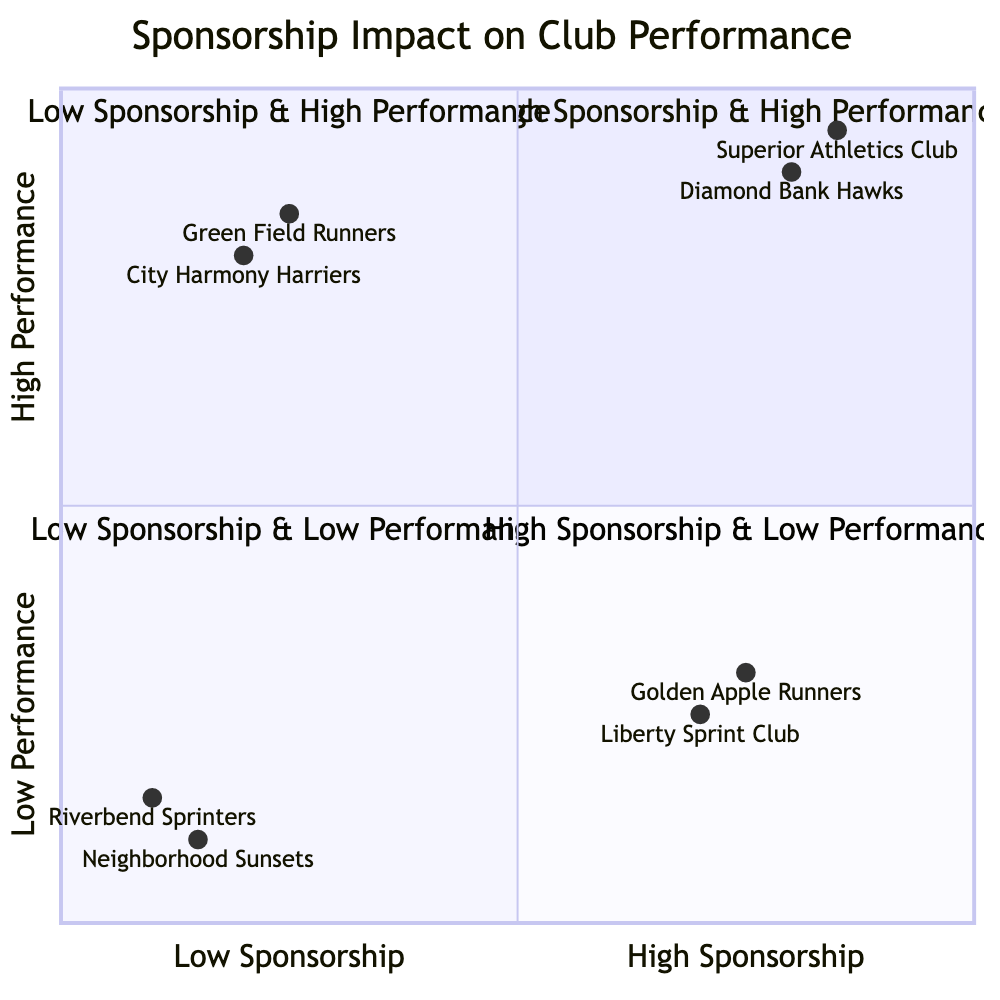What are the two clubs in the "High Sponsorship & High Performance" quadrant? In the "High Sponsorship & High Performance" quadrant, the clubs listed are the Diamond Bank Hawks and the Superior Athletics Club.
Answer: Diamond Bank Hawks, Superior Athletics Club How many clubs are classified under "Low Sponsorship & Low Performance"? There are two clubs classified under "Low Sponsorship & Low Performance" which are Neighborhood Sunsets and Riverbend Sprinters.
Answer: 2 Which quadrant contains the Golden Apple Runners? The Golden Apple Runners are located in the "High Sponsorship & Low Performance" quadrant, as they are characterized by significant financial resources but lack strategic execution.
Answer: High Sponsorship & Low Performance What characterizes the clubs in the "Low Sponsorship & High Performance" quadrant? Clubs in the "Low Sponsorship & High Performance" quadrant are characterized by limited financial resources, highly motivated athletes, strong community support, and efficient use of available resources.
Answer: Limited financial resources, highly motivated athletes, strong community support, efficient resource use Which club has the highest performance level? Both the Diamond Bank Hawks and the Superior Athletics Club have the highest performance level, with respective performance values of 0.9 and 0.95.
Answer: Superior Athletics Club How many total clubs are represented in this quadrant chart? The total number of clubs represented is eight, as we have two clubs in each of the four quadrants.
Answer: 8 Which quadrant is the City Harmony Harriers located in? The City Harmony Harriers are located in the "Low Sponsorship & High Performance" quadrant, indicating that despite limited sponsorship, they perform well.
Answer: Low Sponsorship & High Performance What is the common issue faced by clubs in the "High Sponsorship & Low Performance" quadrant? Clubs in this quadrant share a common issue of lacking strategic planning and execution despite having significant financial resources.
Answer: Lack of strategic planning 